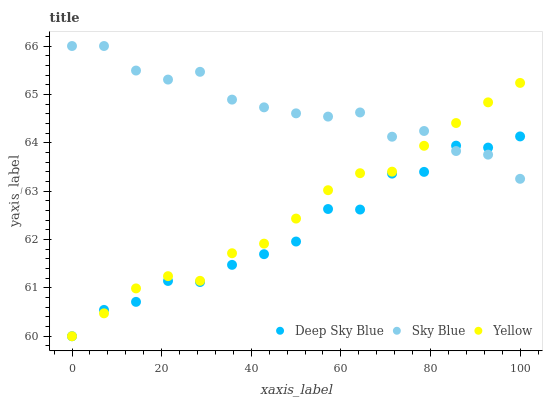Does Deep Sky Blue have the minimum area under the curve?
Answer yes or no. Yes. Does Sky Blue have the maximum area under the curve?
Answer yes or no. Yes. Does Yellow have the minimum area under the curve?
Answer yes or no. No. Does Yellow have the maximum area under the curve?
Answer yes or no. No. Is Yellow the smoothest?
Answer yes or no. Yes. Is Deep Sky Blue the roughest?
Answer yes or no. Yes. Is Deep Sky Blue the smoothest?
Answer yes or no. No. Is Yellow the roughest?
Answer yes or no. No. Does Yellow have the lowest value?
Answer yes or no. Yes. Does Sky Blue have the highest value?
Answer yes or no. Yes. Does Yellow have the highest value?
Answer yes or no. No. Does Yellow intersect Deep Sky Blue?
Answer yes or no. Yes. Is Yellow less than Deep Sky Blue?
Answer yes or no. No. Is Yellow greater than Deep Sky Blue?
Answer yes or no. No. 